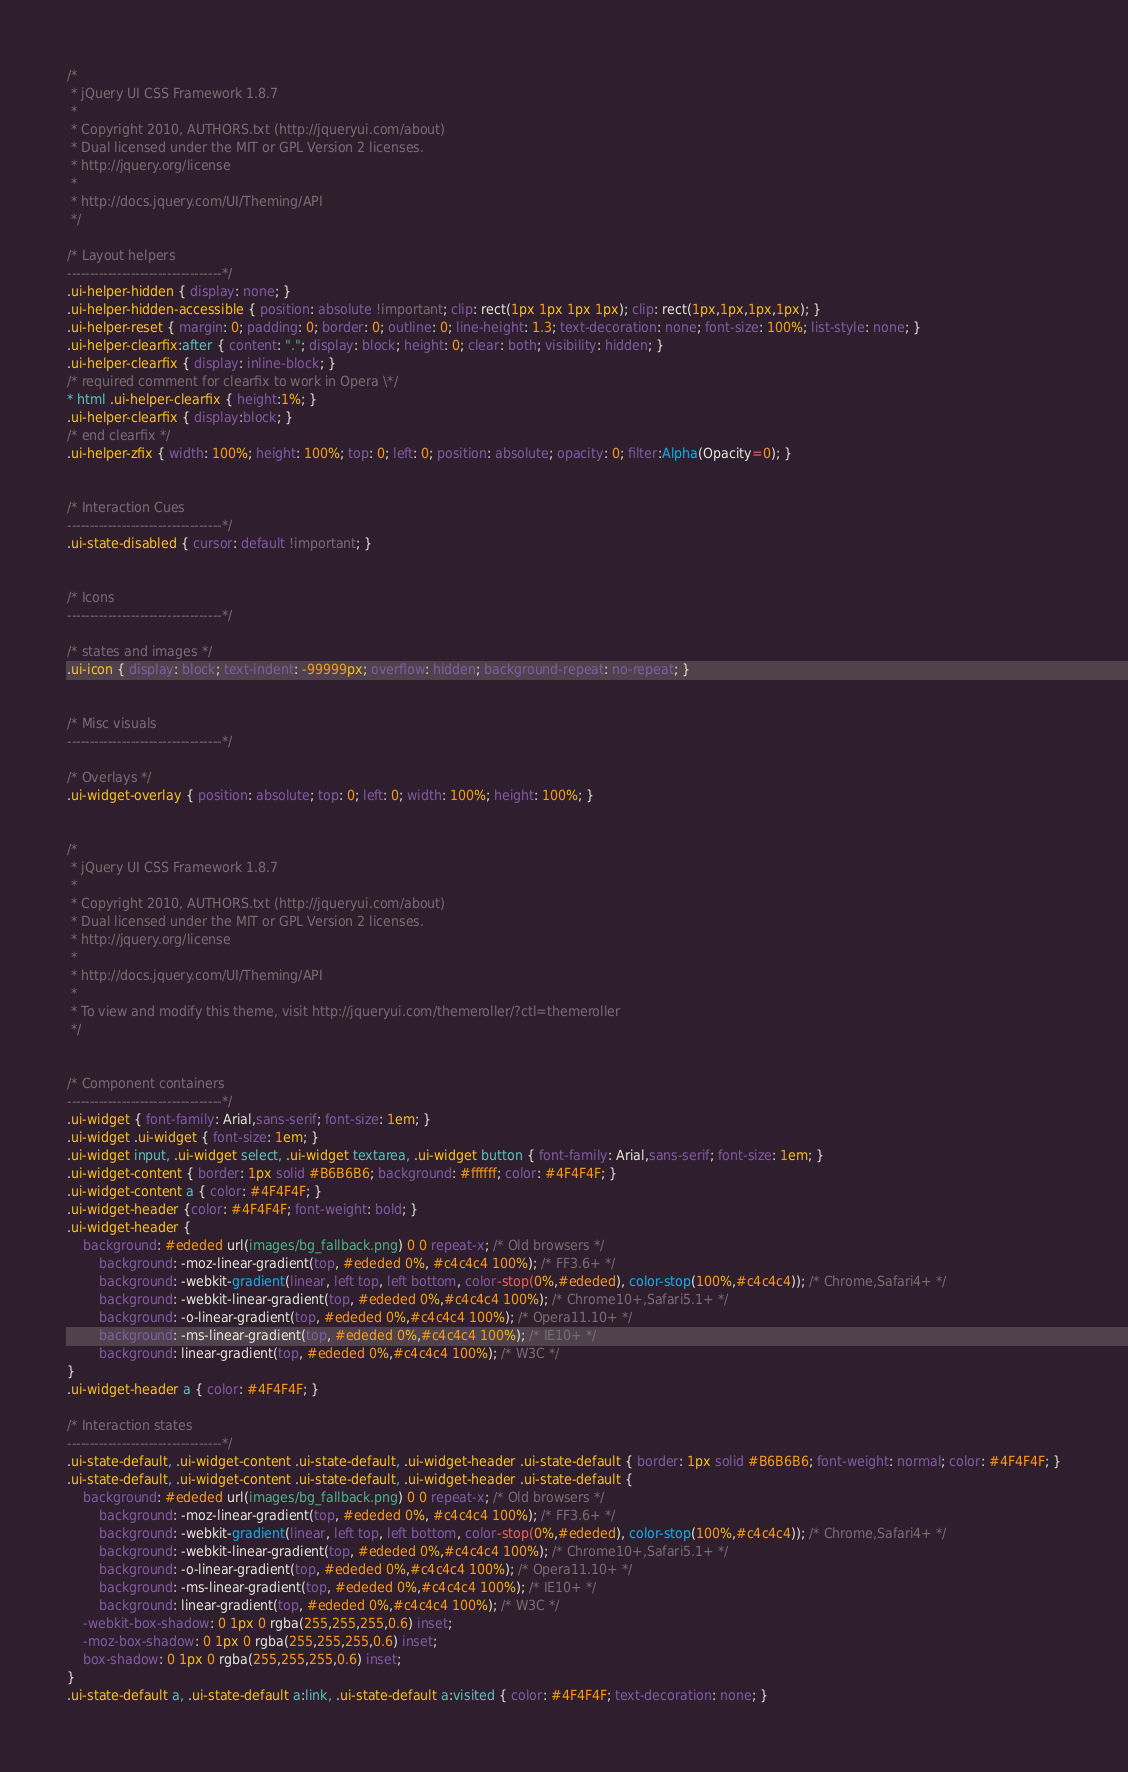Convert code to text. <code><loc_0><loc_0><loc_500><loc_500><_CSS_>/*
 * jQuery UI CSS Framework 1.8.7
 *
 * Copyright 2010, AUTHORS.txt (http://jqueryui.com/about)
 * Dual licensed under the MIT or GPL Version 2 licenses.
 * http://jquery.org/license
 *
 * http://docs.jquery.com/UI/Theming/API
 */

/* Layout helpers
----------------------------------*/
.ui-helper-hidden { display: none; }
.ui-helper-hidden-accessible { position: absolute !important; clip: rect(1px 1px 1px 1px); clip: rect(1px,1px,1px,1px); }
.ui-helper-reset { margin: 0; padding: 0; border: 0; outline: 0; line-height: 1.3; text-decoration: none; font-size: 100%; list-style: none; }
.ui-helper-clearfix:after { content: "."; display: block; height: 0; clear: both; visibility: hidden; }
.ui-helper-clearfix { display: inline-block; }
/* required comment for clearfix to work in Opera \*/
* html .ui-helper-clearfix { height:1%; }
.ui-helper-clearfix { display:block; }
/* end clearfix */
.ui-helper-zfix { width: 100%; height: 100%; top: 0; left: 0; position: absolute; opacity: 0; filter:Alpha(Opacity=0); }


/* Interaction Cues
----------------------------------*/
.ui-state-disabled { cursor: default !important; }


/* Icons
----------------------------------*/

/* states and images */
.ui-icon { display: block; text-indent: -99999px; overflow: hidden; background-repeat: no-repeat; }


/* Misc visuals
----------------------------------*/

/* Overlays */
.ui-widget-overlay { position: absolute; top: 0; left: 0; width: 100%; height: 100%; }


/*
 * jQuery UI CSS Framework 1.8.7
 *
 * Copyright 2010, AUTHORS.txt (http://jqueryui.com/about)
 * Dual licensed under the MIT or GPL Version 2 licenses.
 * http://jquery.org/license
 *
 * http://docs.jquery.com/UI/Theming/API
 *
 * To view and modify this theme, visit http://jqueryui.com/themeroller/?ctl=themeroller
 */


/* Component containers
----------------------------------*/
.ui-widget { font-family: Arial,sans-serif; font-size: 1em; }
.ui-widget .ui-widget { font-size: 1em; }
.ui-widget input, .ui-widget select, .ui-widget textarea, .ui-widget button { font-family: Arial,sans-serif; font-size: 1em; }
.ui-widget-content { border: 1px solid #B6B6B6; background: #ffffff; color: #4F4F4F; }
.ui-widget-content a { color: #4F4F4F; }
.ui-widget-header {color: #4F4F4F; font-weight: bold; }
.ui-widget-header {
	background: #ededed url(images/bg_fallback.png) 0 0 repeat-x; /* Old browsers */
		background: -moz-linear-gradient(top, #ededed 0%, #c4c4c4 100%); /* FF3.6+ */
		background: -webkit-gradient(linear, left top, left bottom, color-stop(0%,#ededed), color-stop(100%,#c4c4c4)); /* Chrome,Safari4+ */
		background: -webkit-linear-gradient(top, #ededed 0%,#c4c4c4 100%); /* Chrome10+,Safari5.1+ */
		background: -o-linear-gradient(top, #ededed 0%,#c4c4c4 100%); /* Opera11.10+ */
		background: -ms-linear-gradient(top, #ededed 0%,#c4c4c4 100%); /* IE10+ */
		background: linear-gradient(top, #ededed 0%,#c4c4c4 100%); /* W3C */
}
.ui-widget-header a { color: #4F4F4F; }

/* Interaction states
----------------------------------*/
.ui-state-default, .ui-widget-content .ui-state-default, .ui-widget-header .ui-state-default { border: 1px solid #B6B6B6; font-weight: normal; color: #4F4F4F; }
.ui-state-default, .ui-widget-content .ui-state-default, .ui-widget-header .ui-state-default { 
	background: #ededed url(images/bg_fallback.png) 0 0 repeat-x; /* Old browsers */
		background: -moz-linear-gradient(top, #ededed 0%, #c4c4c4 100%); /* FF3.6+ */
		background: -webkit-gradient(linear, left top, left bottom, color-stop(0%,#ededed), color-stop(100%,#c4c4c4)); /* Chrome,Safari4+ */
		background: -webkit-linear-gradient(top, #ededed 0%,#c4c4c4 100%); /* Chrome10+,Safari5.1+ */
		background: -o-linear-gradient(top, #ededed 0%,#c4c4c4 100%); /* Opera11.10+ */
		background: -ms-linear-gradient(top, #ededed 0%,#c4c4c4 100%); /* IE10+ */
		background: linear-gradient(top, #ededed 0%,#c4c4c4 100%); /* W3C */
	-webkit-box-shadow: 0 1px 0 rgba(255,255,255,0.6) inset;
	-moz-box-shadow: 0 1px 0 rgba(255,255,255,0.6) inset;
	box-shadow: 0 1px 0 rgba(255,255,255,0.6) inset;
}
.ui-state-default a, .ui-state-default a:link, .ui-state-default a:visited { color: #4F4F4F; text-decoration: none; }</code> 